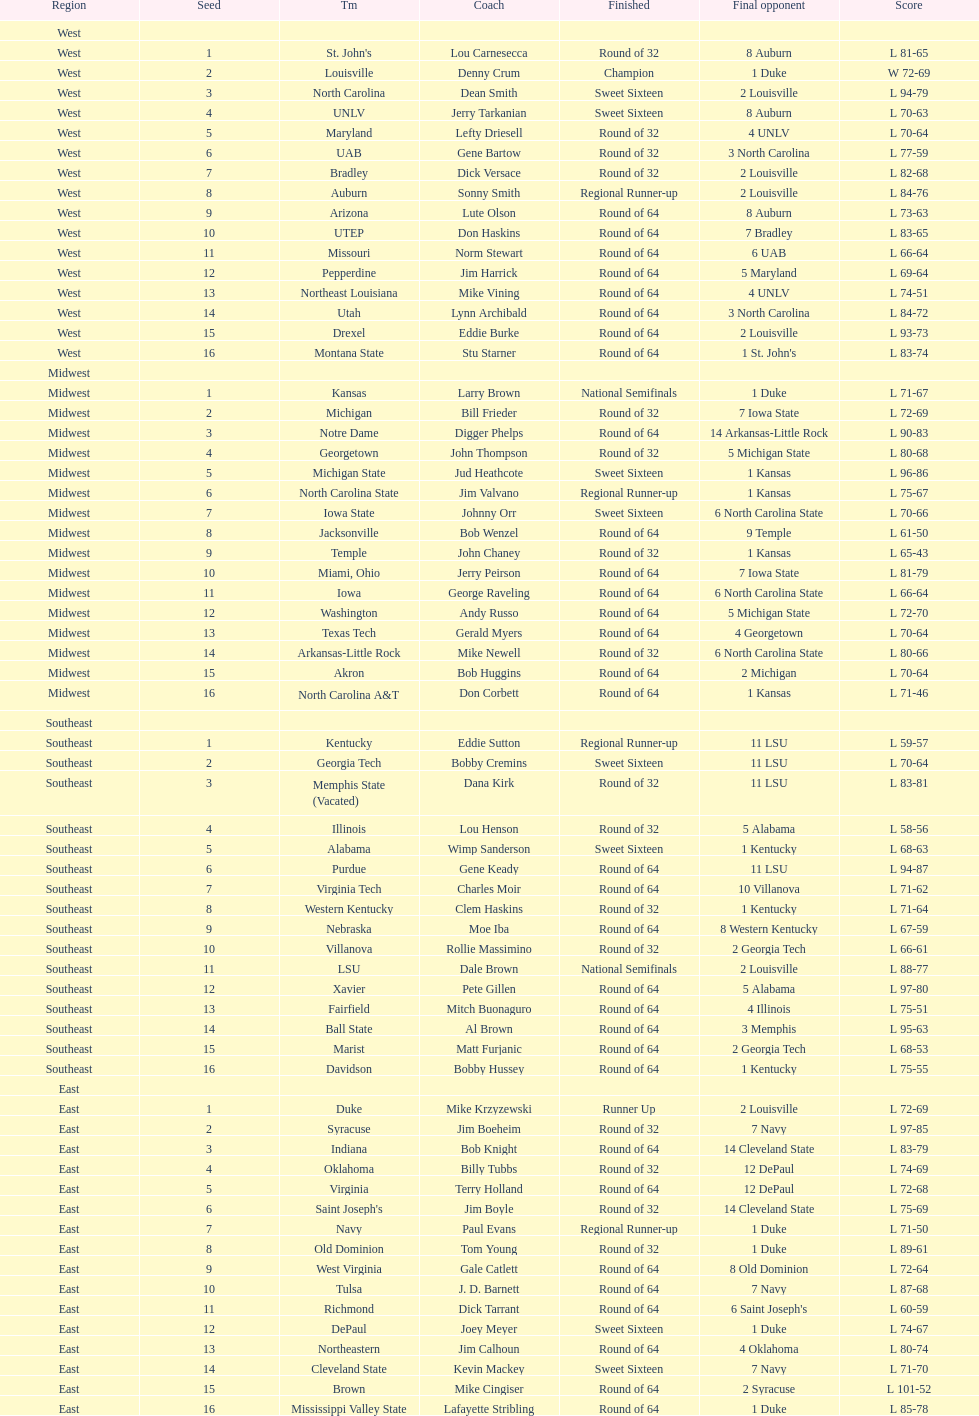What is the overall count of teams that played? 64. 